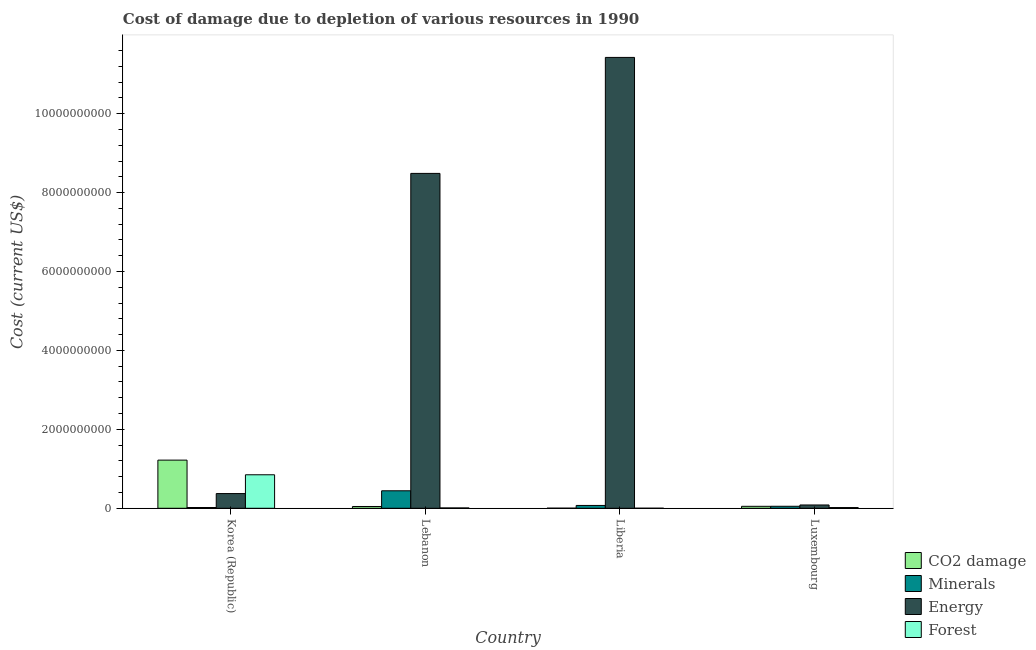How many groups of bars are there?
Offer a terse response. 4. Are the number of bars per tick equal to the number of legend labels?
Offer a very short reply. Yes. Are the number of bars on each tick of the X-axis equal?
Keep it short and to the point. Yes. How many bars are there on the 2nd tick from the left?
Keep it short and to the point. 4. What is the label of the 3rd group of bars from the left?
Keep it short and to the point. Liberia. In how many cases, is the number of bars for a given country not equal to the number of legend labels?
Ensure brevity in your answer.  0. What is the cost of damage due to depletion of minerals in Liberia?
Offer a very short reply. 7.15e+07. Across all countries, what is the maximum cost of damage due to depletion of minerals?
Your response must be concise. 4.43e+08. Across all countries, what is the minimum cost of damage due to depletion of energy?
Offer a very short reply. 8.35e+07. In which country was the cost of damage due to depletion of coal minimum?
Your answer should be compact. Liberia. What is the total cost of damage due to depletion of minerals in the graph?
Your answer should be very brief. 5.85e+08. What is the difference between the cost of damage due to depletion of energy in Liberia and that in Luxembourg?
Your answer should be very brief. 1.13e+1. What is the difference between the cost of damage due to depletion of forests in Lebanon and the cost of damage due to depletion of minerals in Korea (Republic)?
Offer a terse response. -1.10e+07. What is the average cost of damage due to depletion of minerals per country?
Your response must be concise. 1.46e+08. What is the difference between the cost of damage due to depletion of forests and cost of damage due to depletion of coal in Lebanon?
Keep it short and to the point. -3.65e+07. What is the ratio of the cost of damage due to depletion of coal in Liberia to that in Luxembourg?
Provide a short and direct response. 0.05. Is the cost of damage due to depletion of forests in Liberia less than that in Luxembourg?
Offer a terse response. Yes. Is the difference between the cost of damage due to depletion of coal in Liberia and Luxembourg greater than the difference between the cost of damage due to depletion of energy in Liberia and Luxembourg?
Make the answer very short. No. What is the difference between the highest and the second highest cost of damage due to depletion of minerals?
Give a very brief answer. 3.72e+08. What is the difference between the highest and the lowest cost of damage due to depletion of forests?
Provide a succinct answer. 8.48e+08. In how many countries, is the cost of damage due to depletion of forests greater than the average cost of damage due to depletion of forests taken over all countries?
Provide a short and direct response. 1. Is the sum of the cost of damage due to depletion of coal in Korea (Republic) and Luxembourg greater than the maximum cost of damage due to depletion of minerals across all countries?
Your answer should be very brief. Yes. What does the 2nd bar from the left in Lebanon represents?
Offer a very short reply. Minerals. What does the 1st bar from the right in Korea (Republic) represents?
Offer a terse response. Forest. Is it the case that in every country, the sum of the cost of damage due to depletion of coal and cost of damage due to depletion of minerals is greater than the cost of damage due to depletion of energy?
Offer a very short reply. No. How many countries are there in the graph?
Your response must be concise. 4. Are the values on the major ticks of Y-axis written in scientific E-notation?
Give a very brief answer. No. How many legend labels are there?
Provide a short and direct response. 4. How are the legend labels stacked?
Offer a very short reply. Vertical. What is the title of the graph?
Provide a short and direct response. Cost of damage due to depletion of various resources in 1990 . Does "Tracking ability" appear as one of the legend labels in the graph?
Offer a terse response. No. What is the label or title of the Y-axis?
Offer a terse response. Cost (current US$). What is the Cost (current US$) in CO2 damage in Korea (Republic)?
Your answer should be compact. 1.22e+09. What is the Cost (current US$) of Minerals in Korea (Republic)?
Give a very brief answer. 1.94e+07. What is the Cost (current US$) of Energy in Korea (Republic)?
Make the answer very short. 3.73e+08. What is the Cost (current US$) of Forest in Korea (Republic)?
Give a very brief answer. 8.49e+08. What is the Cost (current US$) in CO2 damage in Lebanon?
Keep it short and to the point. 4.50e+07. What is the Cost (current US$) in Minerals in Lebanon?
Keep it short and to the point. 4.43e+08. What is the Cost (current US$) of Energy in Lebanon?
Give a very brief answer. 8.49e+09. What is the Cost (current US$) of Forest in Lebanon?
Provide a short and direct response. 8.45e+06. What is the Cost (current US$) in CO2 damage in Liberia?
Make the answer very short. 2.39e+06. What is the Cost (current US$) of Minerals in Liberia?
Ensure brevity in your answer.  7.15e+07. What is the Cost (current US$) of Energy in Liberia?
Keep it short and to the point. 1.14e+1. What is the Cost (current US$) of Forest in Liberia?
Provide a succinct answer. 9.13e+05. What is the Cost (current US$) in CO2 damage in Luxembourg?
Provide a succinct answer. 4.94e+07. What is the Cost (current US$) in Minerals in Luxembourg?
Give a very brief answer. 5.06e+07. What is the Cost (current US$) in Energy in Luxembourg?
Give a very brief answer. 8.35e+07. What is the Cost (current US$) of Forest in Luxembourg?
Offer a terse response. 1.81e+07. Across all countries, what is the maximum Cost (current US$) in CO2 damage?
Offer a very short reply. 1.22e+09. Across all countries, what is the maximum Cost (current US$) of Minerals?
Your answer should be compact. 4.43e+08. Across all countries, what is the maximum Cost (current US$) of Energy?
Make the answer very short. 1.14e+1. Across all countries, what is the maximum Cost (current US$) in Forest?
Provide a short and direct response. 8.49e+08. Across all countries, what is the minimum Cost (current US$) in CO2 damage?
Your response must be concise. 2.39e+06. Across all countries, what is the minimum Cost (current US$) of Minerals?
Ensure brevity in your answer.  1.94e+07. Across all countries, what is the minimum Cost (current US$) in Energy?
Make the answer very short. 8.35e+07. Across all countries, what is the minimum Cost (current US$) in Forest?
Make the answer very short. 9.13e+05. What is the total Cost (current US$) of CO2 damage in the graph?
Provide a succinct answer. 1.32e+09. What is the total Cost (current US$) in Minerals in the graph?
Provide a short and direct response. 5.85e+08. What is the total Cost (current US$) in Energy in the graph?
Give a very brief answer. 2.04e+1. What is the total Cost (current US$) in Forest in the graph?
Keep it short and to the point. 8.76e+08. What is the difference between the Cost (current US$) in CO2 damage in Korea (Republic) and that in Lebanon?
Your answer should be compact. 1.18e+09. What is the difference between the Cost (current US$) in Minerals in Korea (Republic) and that in Lebanon?
Offer a terse response. -4.24e+08. What is the difference between the Cost (current US$) in Energy in Korea (Republic) and that in Lebanon?
Offer a terse response. -8.11e+09. What is the difference between the Cost (current US$) of Forest in Korea (Republic) and that in Lebanon?
Offer a very short reply. 8.40e+08. What is the difference between the Cost (current US$) of CO2 damage in Korea (Republic) and that in Liberia?
Your response must be concise. 1.22e+09. What is the difference between the Cost (current US$) of Minerals in Korea (Republic) and that in Liberia?
Make the answer very short. -5.21e+07. What is the difference between the Cost (current US$) in Energy in Korea (Republic) and that in Liberia?
Keep it short and to the point. -1.11e+1. What is the difference between the Cost (current US$) of Forest in Korea (Republic) and that in Liberia?
Give a very brief answer. 8.48e+08. What is the difference between the Cost (current US$) of CO2 damage in Korea (Republic) and that in Luxembourg?
Your response must be concise. 1.17e+09. What is the difference between the Cost (current US$) in Minerals in Korea (Republic) and that in Luxembourg?
Your response must be concise. -3.11e+07. What is the difference between the Cost (current US$) of Energy in Korea (Republic) and that in Luxembourg?
Make the answer very short. 2.89e+08. What is the difference between the Cost (current US$) of Forest in Korea (Republic) and that in Luxembourg?
Provide a succinct answer. 8.31e+08. What is the difference between the Cost (current US$) in CO2 damage in Lebanon and that in Liberia?
Ensure brevity in your answer.  4.26e+07. What is the difference between the Cost (current US$) in Minerals in Lebanon and that in Liberia?
Offer a very short reply. 3.72e+08. What is the difference between the Cost (current US$) of Energy in Lebanon and that in Liberia?
Provide a succinct answer. -2.94e+09. What is the difference between the Cost (current US$) of Forest in Lebanon and that in Liberia?
Provide a succinct answer. 7.54e+06. What is the difference between the Cost (current US$) in CO2 damage in Lebanon and that in Luxembourg?
Provide a succinct answer. -4.46e+06. What is the difference between the Cost (current US$) of Minerals in Lebanon and that in Luxembourg?
Your response must be concise. 3.93e+08. What is the difference between the Cost (current US$) in Energy in Lebanon and that in Luxembourg?
Your response must be concise. 8.40e+09. What is the difference between the Cost (current US$) in Forest in Lebanon and that in Luxembourg?
Ensure brevity in your answer.  -9.63e+06. What is the difference between the Cost (current US$) in CO2 damage in Liberia and that in Luxembourg?
Your answer should be compact. -4.70e+07. What is the difference between the Cost (current US$) in Minerals in Liberia and that in Luxembourg?
Ensure brevity in your answer.  2.10e+07. What is the difference between the Cost (current US$) in Energy in Liberia and that in Luxembourg?
Your answer should be very brief. 1.13e+1. What is the difference between the Cost (current US$) in Forest in Liberia and that in Luxembourg?
Give a very brief answer. -1.72e+07. What is the difference between the Cost (current US$) in CO2 damage in Korea (Republic) and the Cost (current US$) in Minerals in Lebanon?
Give a very brief answer. 7.77e+08. What is the difference between the Cost (current US$) in CO2 damage in Korea (Republic) and the Cost (current US$) in Energy in Lebanon?
Provide a short and direct response. -7.27e+09. What is the difference between the Cost (current US$) of CO2 damage in Korea (Republic) and the Cost (current US$) of Forest in Lebanon?
Your answer should be very brief. 1.21e+09. What is the difference between the Cost (current US$) in Minerals in Korea (Republic) and the Cost (current US$) in Energy in Lebanon?
Ensure brevity in your answer.  -8.47e+09. What is the difference between the Cost (current US$) of Minerals in Korea (Republic) and the Cost (current US$) of Forest in Lebanon?
Give a very brief answer. 1.10e+07. What is the difference between the Cost (current US$) of Energy in Korea (Republic) and the Cost (current US$) of Forest in Lebanon?
Give a very brief answer. 3.64e+08. What is the difference between the Cost (current US$) of CO2 damage in Korea (Republic) and the Cost (current US$) of Minerals in Liberia?
Offer a terse response. 1.15e+09. What is the difference between the Cost (current US$) in CO2 damage in Korea (Republic) and the Cost (current US$) in Energy in Liberia?
Offer a terse response. -1.02e+1. What is the difference between the Cost (current US$) in CO2 damage in Korea (Republic) and the Cost (current US$) in Forest in Liberia?
Offer a very short reply. 1.22e+09. What is the difference between the Cost (current US$) in Minerals in Korea (Republic) and the Cost (current US$) in Energy in Liberia?
Your response must be concise. -1.14e+1. What is the difference between the Cost (current US$) of Minerals in Korea (Republic) and the Cost (current US$) of Forest in Liberia?
Ensure brevity in your answer.  1.85e+07. What is the difference between the Cost (current US$) in Energy in Korea (Republic) and the Cost (current US$) in Forest in Liberia?
Make the answer very short. 3.72e+08. What is the difference between the Cost (current US$) in CO2 damage in Korea (Republic) and the Cost (current US$) in Minerals in Luxembourg?
Your response must be concise. 1.17e+09. What is the difference between the Cost (current US$) in CO2 damage in Korea (Republic) and the Cost (current US$) in Energy in Luxembourg?
Provide a succinct answer. 1.14e+09. What is the difference between the Cost (current US$) of CO2 damage in Korea (Republic) and the Cost (current US$) of Forest in Luxembourg?
Make the answer very short. 1.20e+09. What is the difference between the Cost (current US$) in Minerals in Korea (Republic) and the Cost (current US$) in Energy in Luxembourg?
Offer a terse response. -6.40e+07. What is the difference between the Cost (current US$) in Minerals in Korea (Republic) and the Cost (current US$) in Forest in Luxembourg?
Keep it short and to the point. 1.36e+06. What is the difference between the Cost (current US$) of Energy in Korea (Republic) and the Cost (current US$) of Forest in Luxembourg?
Your answer should be very brief. 3.55e+08. What is the difference between the Cost (current US$) of CO2 damage in Lebanon and the Cost (current US$) of Minerals in Liberia?
Your answer should be very brief. -2.66e+07. What is the difference between the Cost (current US$) in CO2 damage in Lebanon and the Cost (current US$) in Energy in Liberia?
Your response must be concise. -1.14e+1. What is the difference between the Cost (current US$) in CO2 damage in Lebanon and the Cost (current US$) in Forest in Liberia?
Your answer should be very brief. 4.41e+07. What is the difference between the Cost (current US$) in Minerals in Lebanon and the Cost (current US$) in Energy in Liberia?
Your response must be concise. -1.10e+1. What is the difference between the Cost (current US$) in Minerals in Lebanon and the Cost (current US$) in Forest in Liberia?
Offer a very short reply. 4.42e+08. What is the difference between the Cost (current US$) of Energy in Lebanon and the Cost (current US$) of Forest in Liberia?
Provide a short and direct response. 8.49e+09. What is the difference between the Cost (current US$) of CO2 damage in Lebanon and the Cost (current US$) of Minerals in Luxembourg?
Make the answer very short. -5.58e+06. What is the difference between the Cost (current US$) of CO2 damage in Lebanon and the Cost (current US$) of Energy in Luxembourg?
Give a very brief answer. -3.85e+07. What is the difference between the Cost (current US$) of CO2 damage in Lebanon and the Cost (current US$) of Forest in Luxembourg?
Make the answer very short. 2.69e+07. What is the difference between the Cost (current US$) of Minerals in Lebanon and the Cost (current US$) of Energy in Luxembourg?
Offer a terse response. 3.60e+08. What is the difference between the Cost (current US$) of Minerals in Lebanon and the Cost (current US$) of Forest in Luxembourg?
Keep it short and to the point. 4.25e+08. What is the difference between the Cost (current US$) of Energy in Lebanon and the Cost (current US$) of Forest in Luxembourg?
Give a very brief answer. 8.47e+09. What is the difference between the Cost (current US$) of CO2 damage in Liberia and the Cost (current US$) of Minerals in Luxembourg?
Provide a short and direct response. -4.82e+07. What is the difference between the Cost (current US$) in CO2 damage in Liberia and the Cost (current US$) in Energy in Luxembourg?
Your answer should be very brief. -8.11e+07. What is the difference between the Cost (current US$) of CO2 damage in Liberia and the Cost (current US$) of Forest in Luxembourg?
Provide a short and direct response. -1.57e+07. What is the difference between the Cost (current US$) in Minerals in Liberia and the Cost (current US$) in Energy in Luxembourg?
Offer a very short reply. -1.20e+07. What is the difference between the Cost (current US$) in Minerals in Liberia and the Cost (current US$) in Forest in Luxembourg?
Your answer should be compact. 5.34e+07. What is the difference between the Cost (current US$) in Energy in Liberia and the Cost (current US$) in Forest in Luxembourg?
Your answer should be very brief. 1.14e+1. What is the average Cost (current US$) of CO2 damage per country?
Offer a very short reply. 3.29e+08. What is the average Cost (current US$) in Minerals per country?
Keep it short and to the point. 1.46e+08. What is the average Cost (current US$) of Energy per country?
Offer a very short reply. 5.09e+09. What is the average Cost (current US$) of Forest per country?
Keep it short and to the point. 2.19e+08. What is the difference between the Cost (current US$) in CO2 damage and Cost (current US$) in Minerals in Korea (Republic)?
Offer a terse response. 1.20e+09. What is the difference between the Cost (current US$) of CO2 damage and Cost (current US$) of Energy in Korea (Republic)?
Your answer should be compact. 8.48e+08. What is the difference between the Cost (current US$) in CO2 damage and Cost (current US$) in Forest in Korea (Republic)?
Your answer should be very brief. 3.71e+08. What is the difference between the Cost (current US$) of Minerals and Cost (current US$) of Energy in Korea (Republic)?
Provide a short and direct response. -3.53e+08. What is the difference between the Cost (current US$) in Minerals and Cost (current US$) in Forest in Korea (Republic)?
Provide a succinct answer. -8.29e+08. What is the difference between the Cost (current US$) in Energy and Cost (current US$) in Forest in Korea (Republic)?
Keep it short and to the point. -4.76e+08. What is the difference between the Cost (current US$) of CO2 damage and Cost (current US$) of Minerals in Lebanon?
Make the answer very short. -3.98e+08. What is the difference between the Cost (current US$) of CO2 damage and Cost (current US$) of Energy in Lebanon?
Offer a very short reply. -8.44e+09. What is the difference between the Cost (current US$) of CO2 damage and Cost (current US$) of Forest in Lebanon?
Make the answer very short. 3.65e+07. What is the difference between the Cost (current US$) in Minerals and Cost (current US$) in Energy in Lebanon?
Provide a short and direct response. -8.04e+09. What is the difference between the Cost (current US$) of Minerals and Cost (current US$) of Forest in Lebanon?
Ensure brevity in your answer.  4.35e+08. What is the difference between the Cost (current US$) in Energy and Cost (current US$) in Forest in Lebanon?
Your answer should be compact. 8.48e+09. What is the difference between the Cost (current US$) of CO2 damage and Cost (current US$) of Minerals in Liberia?
Provide a short and direct response. -6.91e+07. What is the difference between the Cost (current US$) in CO2 damage and Cost (current US$) in Energy in Liberia?
Offer a very short reply. -1.14e+1. What is the difference between the Cost (current US$) in CO2 damage and Cost (current US$) in Forest in Liberia?
Your answer should be compact. 1.48e+06. What is the difference between the Cost (current US$) of Minerals and Cost (current US$) of Energy in Liberia?
Keep it short and to the point. -1.14e+1. What is the difference between the Cost (current US$) of Minerals and Cost (current US$) of Forest in Liberia?
Offer a terse response. 7.06e+07. What is the difference between the Cost (current US$) of Energy and Cost (current US$) of Forest in Liberia?
Give a very brief answer. 1.14e+1. What is the difference between the Cost (current US$) in CO2 damage and Cost (current US$) in Minerals in Luxembourg?
Provide a short and direct response. -1.12e+06. What is the difference between the Cost (current US$) of CO2 damage and Cost (current US$) of Energy in Luxembourg?
Make the answer very short. -3.41e+07. What is the difference between the Cost (current US$) of CO2 damage and Cost (current US$) of Forest in Luxembourg?
Offer a terse response. 3.13e+07. What is the difference between the Cost (current US$) in Minerals and Cost (current US$) in Energy in Luxembourg?
Give a very brief answer. -3.29e+07. What is the difference between the Cost (current US$) in Minerals and Cost (current US$) in Forest in Luxembourg?
Give a very brief answer. 3.25e+07. What is the difference between the Cost (current US$) in Energy and Cost (current US$) in Forest in Luxembourg?
Your answer should be very brief. 6.54e+07. What is the ratio of the Cost (current US$) in CO2 damage in Korea (Republic) to that in Lebanon?
Offer a terse response. 27.13. What is the ratio of the Cost (current US$) of Minerals in Korea (Republic) to that in Lebanon?
Keep it short and to the point. 0.04. What is the ratio of the Cost (current US$) in Energy in Korea (Republic) to that in Lebanon?
Your answer should be very brief. 0.04. What is the ratio of the Cost (current US$) in Forest in Korea (Republic) to that in Lebanon?
Offer a terse response. 100.47. What is the ratio of the Cost (current US$) of CO2 damage in Korea (Republic) to that in Liberia?
Provide a succinct answer. 510.17. What is the ratio of the Cost (current US$) in Minerals in Korea (Republic) to that in Liberia?
Provide a succinct answer. 0.27. What is the ratio of the Cost (current US$) of Energy in Korea (Republic) to that in Liberia?
Your answer should be very brief. 0.03. What is the ratio of the Cost (current US$) of Forest in Korea (Republic) to that in Liberia?
Make the answer very short. 930.08. What is the ratio of the Cost (current US$) in CO2 damage in Korea (Republic) to that in Luxembourg?
Provide a short and direct response. 24.69. What is the ratio of the Cost (current US$) of Minerals in Korea (Republic) to that in Luxembourg?
Your answer should be very brief. 0.38. What is the ratio of the Cost (current US$) in Energy in Korea (Republic) to that in Luxembourg?
Your answer should be compact. 4.46. What is the ratio of the Cost (current US$) in Forest in Korea (Republic) to that in Luxembourg?
Ensure brevity in your answer.  46.94. What is the ratio of the Cost (current US$) in CO2 damage in Lebanon to that in Liberia?
Your answer should be compact. 18.8. What is the ratio of the Cost (current US$) in Minerals in Lebanon to that in Liberia?
Your answer should be compact. 6.2. What is the ratio of the Cost (current US$) of Energy in Lebanon to that in Liberia?
Make the answer very short. 0.74. What is the ratio of the Cost (current US$) in Forest in Lebanon to that in Liberia?
Your answer should be compact. 9.26. What is the ratio of the Cost (current US$) in CO2 damage in Lebanon to that in Luxembourg?
Your response must be concise. 0.91. What is the ratio of the Cost (current US$) in Minerals in Lebanon to that in Luxembourg?
Provide a succinct answer. 8.77. What is the ratio of the Cost (current US$) in Energy in Lebanon to that in Luxembourg?
Provide a short and direct response. 101.65. What is the ratio of the Cost (current US$) of Forest in Lebanon to that in Luxembourg?
Provide a short and direct response. 0.47. What is the ratio of the Cost (current US$) of CO2 damage in Liberia to that in Luxembourg?
Make the answer very short. 0.05. What is the ratio of the Cost (current US$) in Minerals in Liberia to that in Luxembourg?
Your response must be concise. 1.42. What is the ratio of the Cost (current US$) in Energy in Liberia to that in Luxembourg?
Give a very brief answer. 136.86. What is the ratio of the Cost (current US$) of Forest in Liberia to that in Luxembourg?
Offer a very short reply. 0.05. What is the difference between the highest and the second highest Cost (current US$) in CO2 damage?
Your answer should be compact. 1.17e+09. What is the difference between the highest and the second highest Cost (current US$) in Minerals?
Offer a terse response. 3.72e+08. What is the difference between the highest and the second highest Cost (current US$) of Energy?
Your response must be concise. 2.94e+09. What is the difference between the highest and the second highest Cost (current US$) of Forest?
Give a very brief answer. 8.31e+08. What is the difference between the highest and the lowest Cost (current US$) in CO2 damage?
Offer a terse response. 1.22e+09. What is the difference between the highest and the lowest Cost (current US$) in Minerals?
Give a very brief answer. 4.24e+08. What is the difference between the highest and the lowest Cost (current US$) of Energy?
Provide a short and direct response. 1.13e+1. What is the difference between the highest and the lowest Cost (current US$) in Forest?
Give a very brief answer. 8.48e+08. 